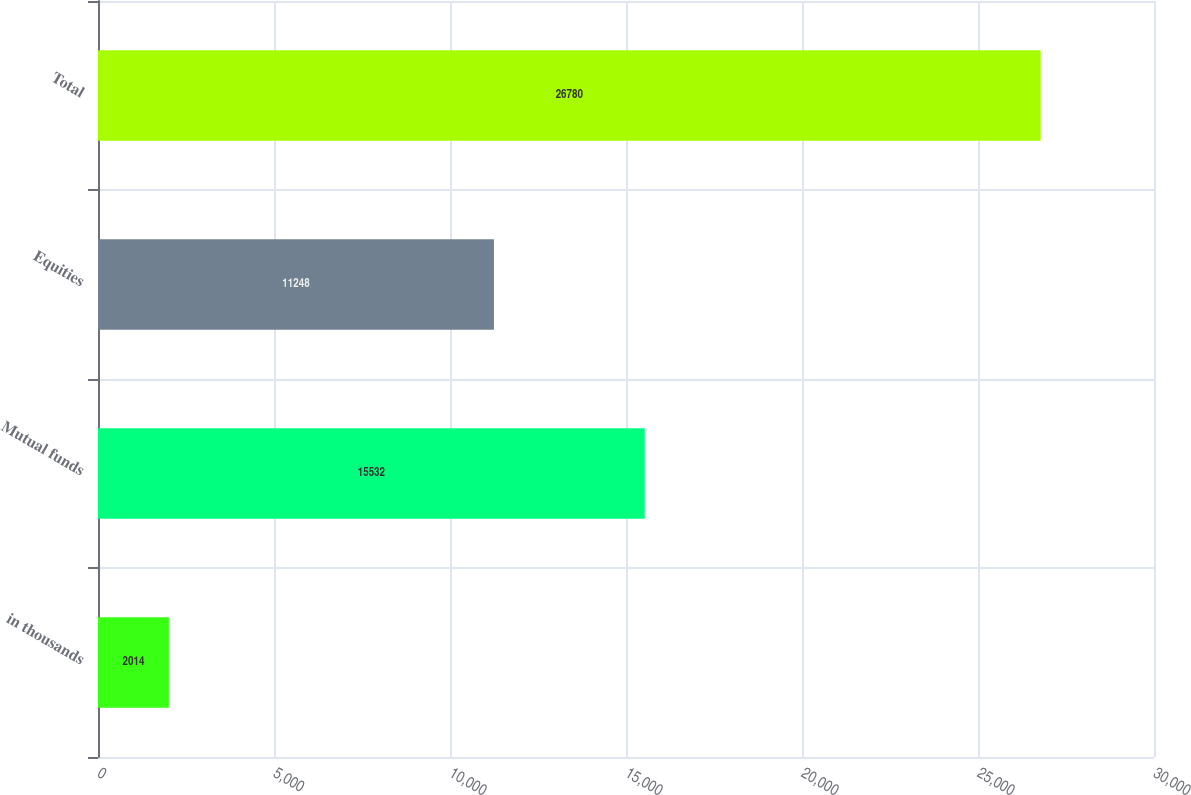<chart> <loc_0><loc_0><loc_500><loc_500><bar_chart><fcel>in thousands<fcel>Mutual funds<fcel>Equities<fcel>Total<nl><fcel>2014<fcel>15532<fcel>11248<fcel>26780<nl></chart> 